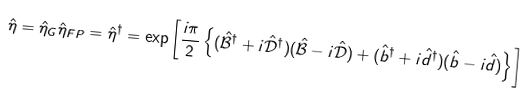Convert formula to latex. <formula><loc_0><loc_0><loc_500><loc_500>\hat { \eta } = \hat { \eta } _ { G } \hat { \eta } _ { F P } = \hat { \eta } ^ { \dagger } = \exp \left [ \frac { i \pi } { 2 } \left \{ ( \hat { \mathcal { B } } ^ { \dagger } + i \hat { \mathcal { D } } ^ { \dagger } ) ( \hat { \mathcal { B } } - i \hat { \mathcal { D } } ) + ( \hat { b } ^ { \dagger } + i \hat { d } ^ { \dagger } ) ( \hat { b } - i \hat { d } ) \right \} \right ]</formula> 